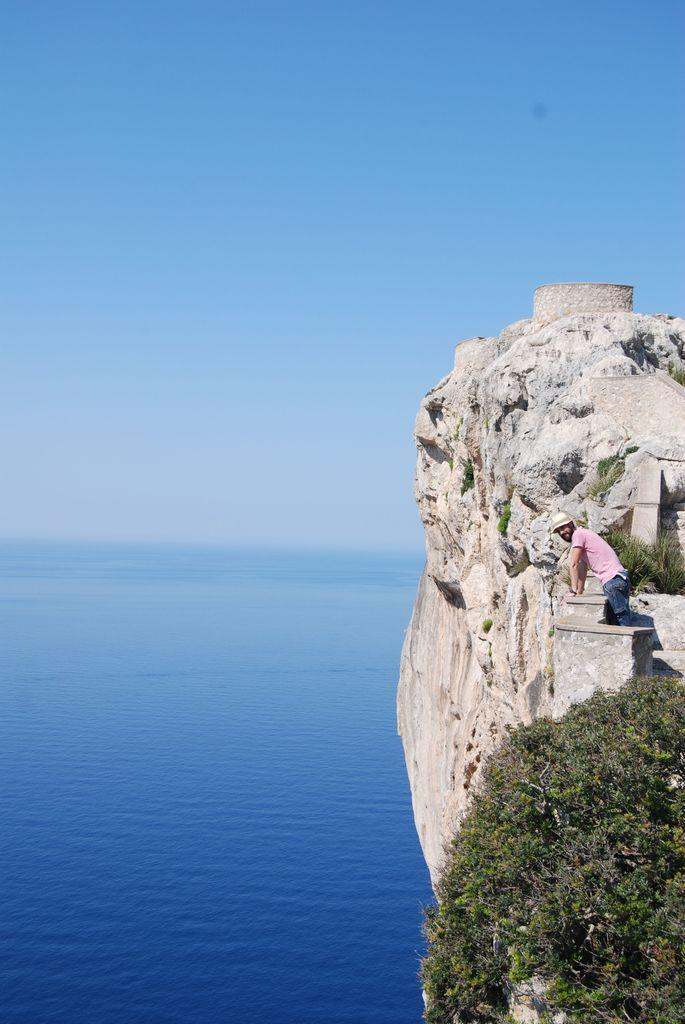Please provide a concise description of this image. In this image we can see a person standing at the hill, trees, ocean and sky. 